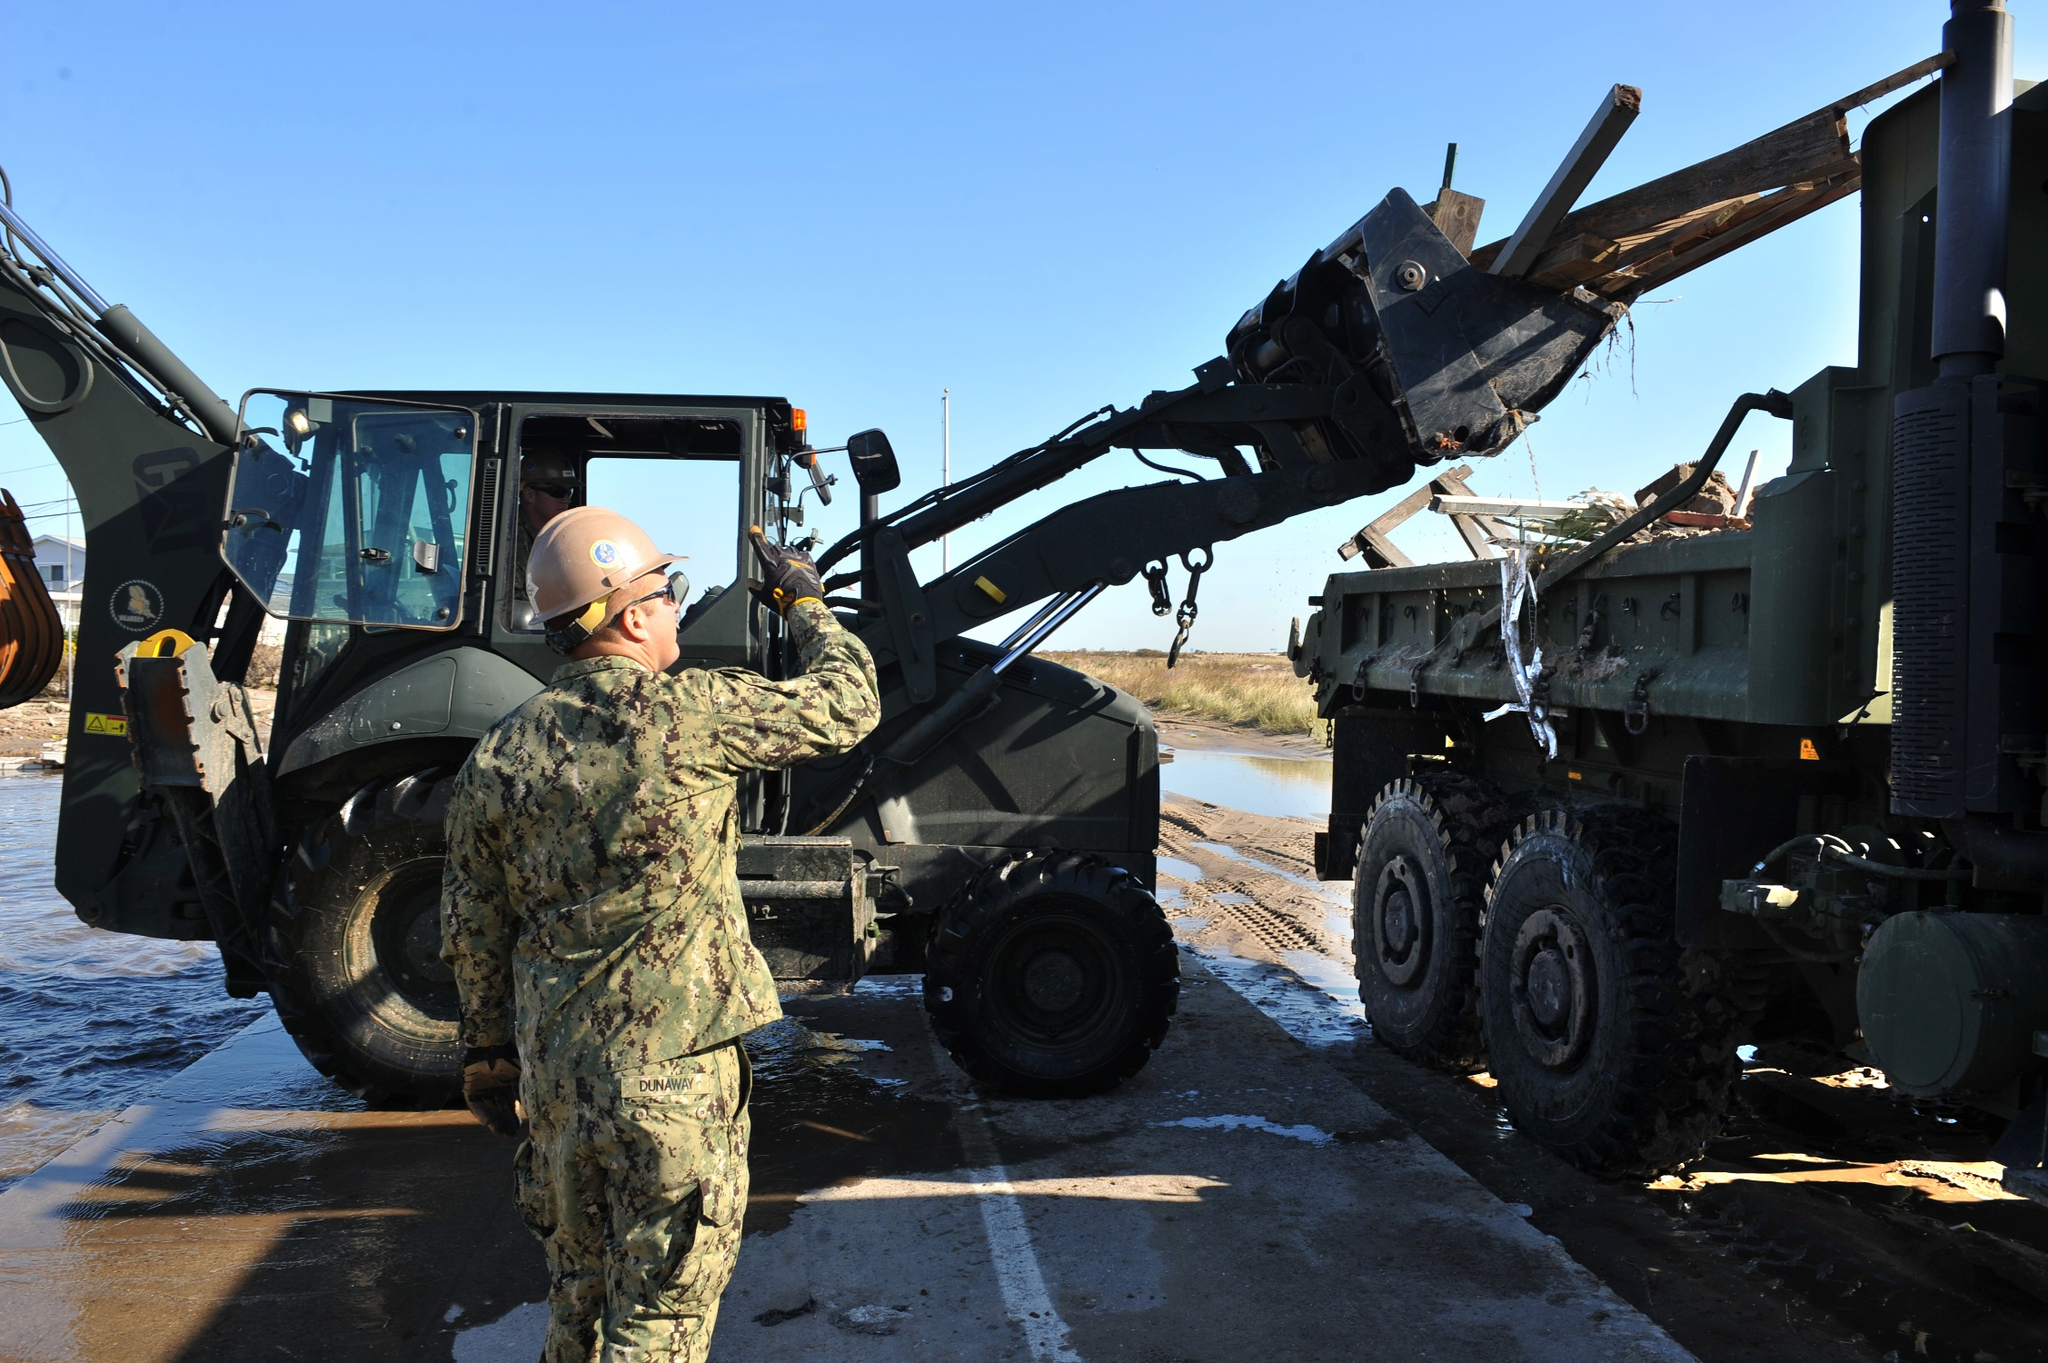What could be a realistic conversation between two workers at this site? Worker 1: “Hey, how’s it going with the forklift? Those beams are pretty hefty.”
Worker 2: “It’s going well, just need to take it slow and steady. These beams are critical for the new support structure. How's it on your end?”
Worker 1: “We’re making good progress too. The foundation is almost set. Once you’re done here, we can start on the main framework.”
Worker 2: “Sounds good. Let’s hope the weather stays clear so we can keep up this pace.”
Worker 1: “Yeah, fingers crossed. This project is crucial—everyone’s counting on us.”
Worker 2: “Absolutely. Let's get it done right.” 